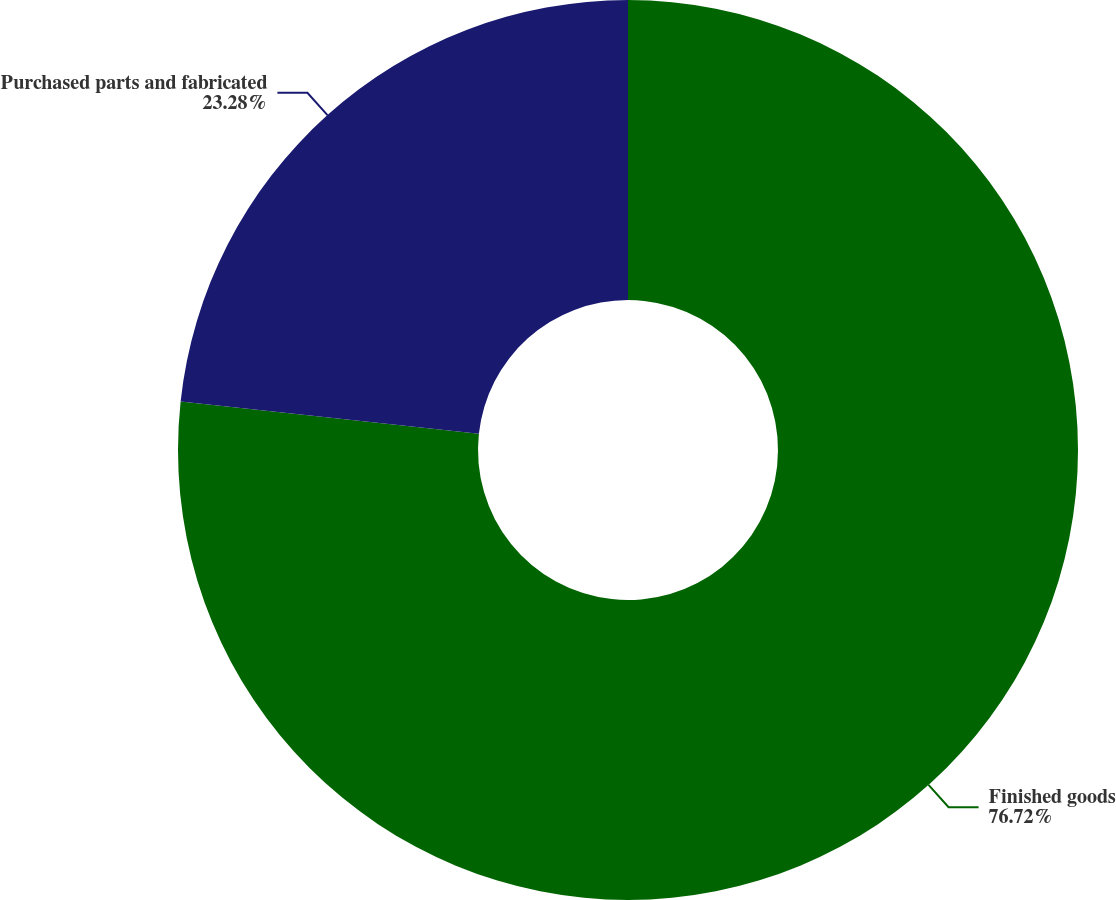Convert chart to OTSL. <chart><loc_0><loc_0><loc_500><loc_500><pie_chart><fcel>Finished goods<fcel>Purchased parts and fabricated<nl><fcel>76.72%<fcel>23.28%<nl></chart> 